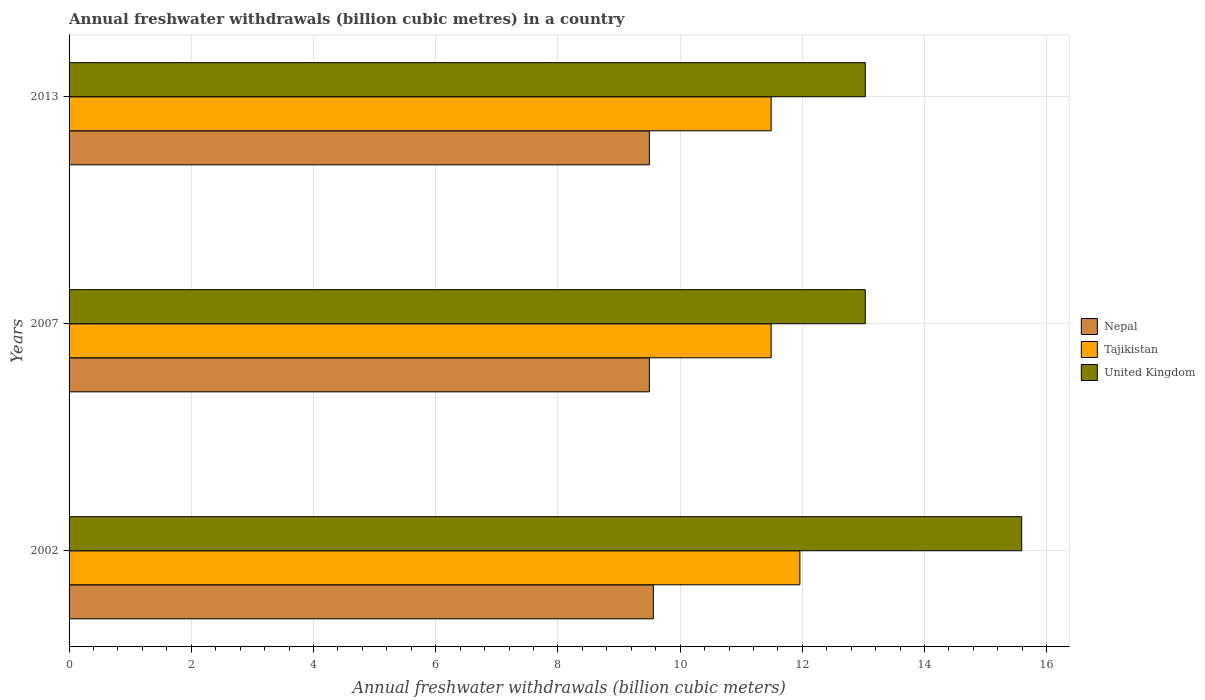Are the number of bars per tick equal to the number of legend labels?
Give a very brief answer. Yes. Are the number of bars on each tick of the Y-axis equal?
Your answer should be very brief. Yes. How many bars are there on the 2nd tick from the top?
Provide a succinct answer. 3. What is the label of the 3rd group of bars from the top?
Offer a very short reply. 2002. In how many cases, is the number of bars for a given year not equal to the number of legend labels?
Provide a short and direct response. 0. What is the annual freshwater withdrawals in Nepal in 2007?
Your response must be concise. 9.5. Across all years, what is the maximum annual freshwater withdrawals in Nepal?
Keep it short and to the point. 9.56. Across all years, what is the minimum annual freshwater withdrawals in United Kingdom?
Offer a terse response. 13.03. What is the total annual freshwater withdrawals in Tajikistan in the graph?
Give a very brief answer. 34.94. What is the difference between the annual freshwater withdrawals in United Kingdom in 2002 and that in 2013?
Offer a very short reply. 2.56. What is the difference between the annual freshwater withdrawals in Nepal in 2007 and the annual freshwater withdrawals in United Kingdom in 2002?
Your response must be concise. -6.09. What is the average annual freshwater withdrawals in Nepal per year?
Offer a terse response. 9.52. In the year 2007, what is the difference between the annual freshwater withdrawals in Nepal and annual freshwater withdrawals in Tajikistan?
Give a very brief answer. -1.99. What is the ratio of the annual freshwater withdrawals in Tajikistan in 2002 to that in 2013?
Make the answer very short. 1.04. Is the difference between the annual freshwater withdrawals in Nepal in 2007 and 2013 greater than the difference between the annual freshwater withdrawals in Tajikistan in 2007 and 2013?
Provide a succinct answer. No. What is the difference between the highest and the second highest annual freshwater withdrawals in Nepal?
Your answer should be very brief. 0.06. What is the difference between the highest and the lowest annual freshwater withdrawals in Nepal?
Your answer should be compact. 0.06. Is the sum of the annual freshwater withdrawals in United Kingdom in 2007 and 2013 greater than the maximum annual freshwater withdrawals in Nepal across all years?
Provide a short and direct response. Yes. What does the 1st bar from the top in 2002 represents?
Keep it short and to the point. United Kingdom. What does the 1st bar from the bottom in 2013 represents?
Ensure brevity in your answer.  Nepal. Is it the case that in every year, the sum of the annual freshwater withdrawals in Tajikistan and annual freshwater withdrawals in United Kingdom is greater than the annual freshwater withdrawals in Nepal?
Offer a terse response. Yes. Are all the bars in the graph horizontal?
Offer a terse response. Yes. How many years are there in the graph?
Make the answer very short. 3. What is the difference between two consecutive major ticks on the X-axis?
Provide a short and direct response. 2. Are the values on the major ticks of X-axis written in scientific E-notation?
Your answer should be compact. No. Does the graph contain any zero values?
Your response must be concise. No. Does the graph contain grids?
Keep it short and to the point. Yes. Where does the legend appear in the graph?
Offer a very short reply. Center right. How many legend labels are there?
Offer a terse response. 3. What is the title of the graph?
Provide a short and direct response. Annual freshwater withdrawals (billion cubic metres) in a country. What is the label or title of the X-axis?
Ensure brevity in your answer.  Annual freshwater withdrawals (billion cubic meters). What is the label or title of the Y-axis?
Make the answer very short. Years. What is the Annual freshwater withdrawals (billion cubic meters) in Nepal in 2002?
Make the answer very short. 9.56. What is the Annual freshwater withdrawals (billion cubic meters) of Tajikistan in 2002?
Your response must be concise. 11.96. What is the Annual freshwater withdrawals (billion cubic meters) of United Kingdom in 2002?
Provide a short and direct response. 15.59. What is the Annual freshwater withdrawals (billion cubic meters) of Nepal in 2007?
Keep it short and to the point. 9.5. What is the Annual freshwater withdrawals (billion cubic meters) in Tajikistan in 2007?
Keep it short and to the point. 11.49. What is the Annual freshwater withdrawals (billion cubic meters) of United Kingdom in 2007?
Make the answer very short. 13.03. What is the Annual freshwater withdrawals (billion cubic meters) in Nepal in 2013?
Provide a short and direct response. 9.5. What is the Annual freshwater withdrawals (billion cubic meters) of Tajikistan in 2013?
Provide a succinct answer. 11.49. What is the Annual freshwater withdrawals (billion cubic meters) in United Kingdom in 2013?
Keep it short and to the point. 13.03. Across all years, what is the maximum Annual freshwater withdrawals (billion cubic meters) of Nepal?
Your answer should be compact. 9.56. Across all years, what is the maximum Annual freshwater withdrawals (billion cubic meters) of Tajikistan?
Your answer should be compact. 11.96. Across all years, what is the maximum Annual freshwater withdrawals (billion cubic meters) in United Kingdom?
Provide a short and direct response. 15.59. Across all years, what is the minimum Annual freshwater withdrawals (billion cubic meters) of Nepal?
Provide a short and direct response. 9.5. Across all years, what is the minimum Annual freshwater withdrawals (billion cubic meters) of Tajikistan?
Give a very brief answer. 11.49. Across all years, what is the minimum Annual freshwater withdrawals (billion cubic meters) in United Kingdom?
Offer a very short reply. 13.03. What is the total Annual freshwater withdrawals (billion cubic meters) of Nepal in the graph?
Provide a short and direct response. 28.56. What is the total Annual freshwater withdrawals (billion cubic meters) in Tajikistan in the graph?
Make the answer very short. 34.94. What is the total Annual freshwater withdrawals (billion cubic meters) of United Kingdom in the graph?
Your response must be concise. 41.65. What is the difference between the Annual freshwater withdrawals (billion cubic meters) in Nepal in 2002 and that in 2007?
Ensure brevity in your answer.  0.07. What is the difference between the Annual freshwater withdrawals (billion cubic meters) of Tajikistan in 2002 and that in 2007?
Give a very brief answer. 0.47. What is the difference between the Annual freshwater withdrawals (billion cubic meters) of United Kingdom in 2002 and that in 2007?
Ensure brevity in your answer.  2.56. What is the difference between the Annual freshwater withdrawals (billion cubic meters) in Nepal in 2002 and that in 2013?
Give a very brief answer. 0.07. What is the difference between the Annual freshwater withdrawals (billion cubic meters) in Tajikistan in 2002 and that in 2013?
Ensure brevity in your answer.  0.47. What is the difference between the Annual freshwater withdrawals (billion cubic meters) in United Kingdom in 2002 and that in 2013?
Your response must be concise. 2.56. What is the difference between the Annual freshwater withdrawals (billion cubic meters) in Tajikistan in 2007 and that in 2013?
Keep it short and to the point. 0. What is the difference between the Annual freshwater withdrawals (billion cubic meters) in Nepal in 2002 and the Annual freshwater withdrawals (billion cubic meters) in Tajikistan in 2007?
Your answer should be compact. -1.93. What is the difference between the Annual freshwater withdrawals (billion cubic meters) of Nepal in 2002 and the Annual freshwater withdrawals (billion cubic meters) of United Kingdom in 2007?
Your answer should be compact. -3.47. What is the difference between the Annual freshwater withdrawals (billion cubic meters) in Tajikistan in 2002 and the Annual freshwater withdrawals (billion cubic meters) in United Kingdom in 2007?
Your answer should be compact. -1.07. What is the difference between the Annual freshwater withdrawals (billion cubic meters) of Nepal in 2002 and the Annual freshwater withdrawals (billion cubic meters) of Tajikistan in 2013?
Offer a terse response. -1.93. What is the difference between the Annual freshwater withdrawals (billion cubic meters) in Nepal in 2002 and the Annual freshwater withdrawals (billion cubic meters) in United Kingdom in 2013?
Keep it short and to the point. -3.47. What is the difference between the Annual freshwater withdrawals (billion cubic meters) of Tajikistan in 2002 and the Annual freshwater withdrawals (billion cubic meters) of United Kingdom in 2013?
Your answer should be very brief. -1.07. What is the difference between the Annual freshwater withdrawals (billion cubic meters) in Nepal in 2007 and the Annual freshwater withdrawals (billion cubic meters) in Tajikistan in 2013?
Keep it short and to the point. -1.99. What is the difference between the Annual freshwater withdrawals (billion cubic meters) in Nepal in 2007 and the Annual freshwater withdrawals (billion cubic meters) in United Kingdom in 2013?
Provide a short and direct response. -3.53. What is the difference between the Annual freshwater withdrawals (billion cubic meters) of Tajikistan in 2007 and the Annual freshwater withdrawals (billion cubic meters) of United Kingdom in 2013?
Make the answer very short. -1.54. What is the average Annual freshwater withdrawals (billion cubic meters) in Nepal per year?
Your answer should be compact. 9.52. What is the average Annual freshwater withdrawals (billion cubic meters) in Tajikistan per year?
Keep it short and to the point. 11.65. What is the average Annual freshwater withdrawals (billion cubic meters) of United Kingdom per year?
Provide a short and direct response. 13.88. In the year 2002, what is the difference between the Annual freshwater withdrawals (billion cubic meters) of Nepal and Annual freshwater withdrawals (billion cubic meters) of Tajikistan?
Provide a succinct answer. -2.4. In the year 2002, what is the difference between the Annual freshwater withdrawals (billion cubic meters) in Nepal and Annual freshwater withdrawals (billion cubic meters) in United Kingdom?
Make the answer very short. -6.03. In the year 2002, what is the difference between the Annual freshwater withdrawals (billion cubic meters) in Tajikistan and Annual freshwater withdrawals (billion cubic meters) in United Kingdom?
Give a very brief answer. -3.63. In the year 2007, what is the difference between the Annual freshwater withdrawals (billion cubic meters) of Nepal and Annual freshwater withdrawals (billion cubic meters) of Tajikistan?
Offer a very short reply. -1.99. In the year 2007, what is the difference between the Annual freshwater withdrawals (billion cubic meters) of Nepal and Annual freshwater withdrawals (billion cubic meters) of United Kingdom?
Your answer should be very brief. -3.53. In the year 2007, what is the difference between the Annual freshwater withdrawals (billion cubic meters) of Tajikistan and Annual freshwater withdrawals (billion cubic meters) of United Kingdom?
Ensure brevity in your answer.  -1.54. In the year 2013, what is the difference between the Annual freshwater withdrawals (billion cubic meters) in Nepal and Annual freshwater withdrawals (billion cubic meters) in Tajikistan?
Offer a very short reply. -1.99. In the year 2013, what is the difference between the Annual freshwater withdrawals (billion cubic meters) in Nepal and Annual freshwater withdrawals (billion cubic meters) in United Kingdom?
Give a very brief answer. -3.53. In the year 2013, what is the difference between the Annual freshwater withdrawals (billion cubic meters) in Tajikistan and Annual freshwater withdrawals (billion cubic meters) in United Kingdom?
Provide a succinct answer. -1.54. What is the ratio of the Annual freshwater withdrawals (billion cubic meters) of Nepal in 2002 to that in 2007?
Provide a short and direct response. 1.01. What is the ratio of the Annual freshwater withdrawals (billion cubic meters) of Tajikistan in 2002 to that in 2007?
Provide a short and direct response. 1.04. What is the ratio of the Annual freshwater withdrawals (billion cubic meters) of United Kingdom in 2002 to that in 2007?
Provide a succinct answer. 1.2. What is the ratio of the Annual freshwater withdrawals (billion cubic meters) in Nepal in 2002 to that in 2013?
Your answer should be very brief. 1.01. What is the ratio of the Annual freshwater withdrawals (billion cubic meters) in Tajikistan in 2002 to that in 2013?
Offer a terse response. 1.04. What is the ratio of the Annual freshwater withdrawals (billion cubic meters) in United Kingdom in 2002 to that in 2013?
Make the answer very short. 1.2. What is the ratio of the Annual freshwater withdrawals (billion cubic meters) in Tajikistan in 2007 to that in 2013?
Provide a succinct answer. 1. What is the difference between the highest and the second highest Annual freshwater withdrawals (billion cubic meters) in Nepal?
Give a very brief answer. 0.07. What is the difference between the highest and the second highest Annual freshwater withdrawals (billion cubic meters) in Tajikistan?
Your answer should be compact. 0.47. What is the difference between the highest and the second highest Annual freshwater withdrawals (billion cubic meters) of United Kingdom?
Your answer should be compact. 2.56. What is the difference between the highest and the lowest Annual freshwater withdrawals (billion cubic meters) of Nepal?
Your response must be concise. 0.07. What is the difference between the highest and the lowest Annual freshwater withdrawals (billion cubic meters) in Tajikistan?
Your answer should be very brief. 0.47. What is the difference between the highest and the lowest Annual freshwater withdrawals (billion cubic meters) in United Kingdom?
Provide a short and direct response. 2.56. 